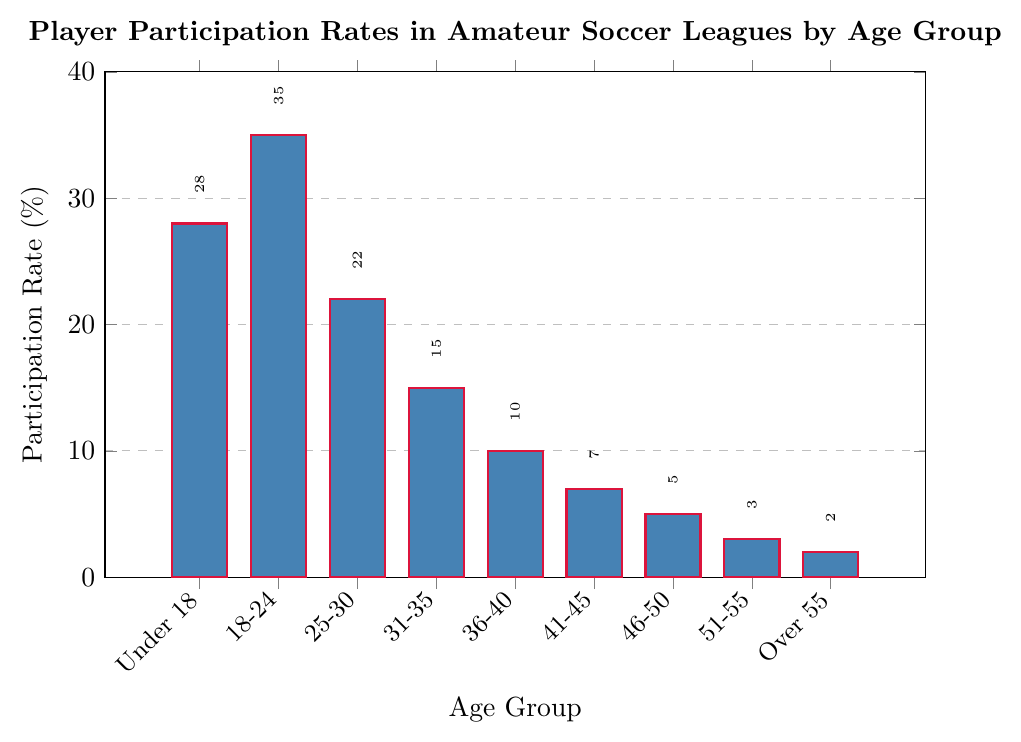What's the age group with the highest participation rate? The highest bar corresponds to the age group 18-24 with a participation rate of 35%.
Answer: 18-24 Which age group has the lowest participation rate? The shortest bar is for the age group "Over 55," which has a participation rate of 2%.
Answer: Over 55 How many age groups have a participation rate above 20%? Count the bars that go above the 20% mark: Under 18 (28%), 18-24 (35%), and 25-30 (22%) – a total of 3 age groups.
Answer: 3 What is the participation rate difference between the age groups 18-24 and 31-35? The participation rate for the age group 18-24 is 35% and for 31-35 it is 15%. The difference is 35% - 15% = 20%.
Answer: 20% Which age group has a participation rate exactly half of that of the Under 18 group? Under 18 has 28%, half of it is 14%. The closest is 31-35 with 15%.
Answer: 31-35 What is the combined participation rate of the age groups 36-40, 41-45, and 46-50? Add the participation rates for 36-40 (10%), 41-45 (7%), and 46-50 (5%): 10% + 7% + 5% = 22%.
Answer: 22% How does the participation rate for the age group 25-30 compare with the average rate of all age groups? Calculate the average participation rate: (28% + 35% + 22% + 15% + 10% + 7% + 5% + 3% + 2%) / 9 = 14.11%, and the rate for 25-30 is 22%, which is higher.
Answer: Higher What is the total participation rate for age groups under 30? Sum the participation rates for Under 18 (28%), 18-24 (35%), and 25-30 (22%): 28% + 35% + 22% = 85%.
Answer: 85% How many age groups have a participation rate of 7% or below? Count the bars with participation rates of 7% or below: 41-45 (7%), 46-50 (5%), 51-55 (3%), Over 55 (2%) – giving a total of 4 age groups.
Answer: 4 